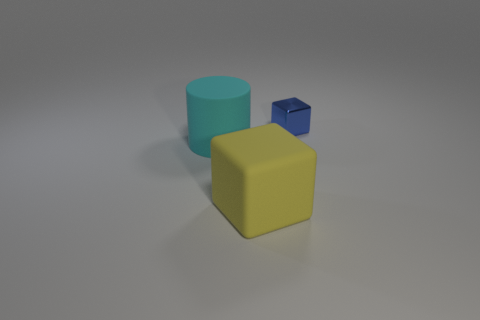Add 3 tiny cyan cylinders. How many objects exist? 6 Subtract all blocks. How many objects are left? 1 Add 1 yellow cubes. How many yellow cubes exist? 2 Subtract 0 brown balls. How many objects are left? 3 Subtract all blue blocks. Subtract all brown spheres. How many objects are left? 2 Add 1 large yellow things. How many large yellow things are left? 2 